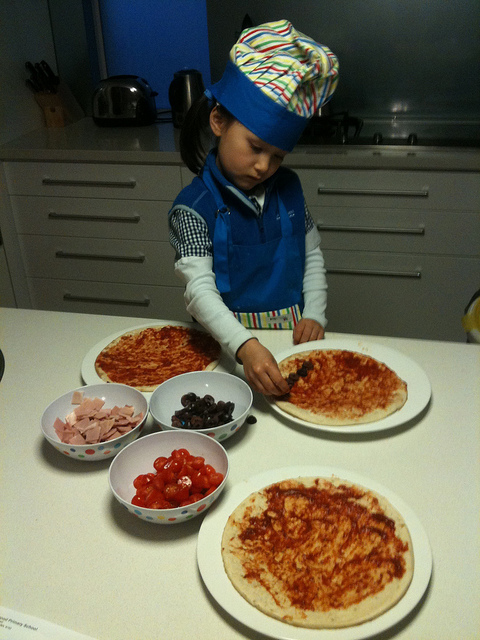<image>Will this child own a pizzeria? I don't know if this child will own a pizzeria in the future. Will this child own a pizzeria? I am not sure if this child will own a pizzeria. It can be both yes or no. 